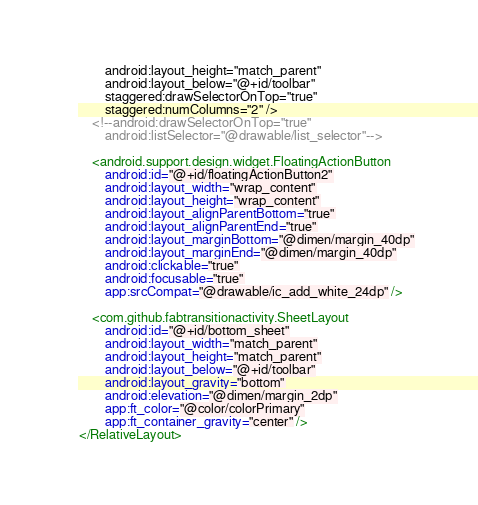Convert code to text. <code><loc_0><loc_0><loc_500><loc_500><_XML_>        android:layout_height="match_parent"
        android:layout_below="@+id/toolbar"
        staggered:drawSelectorOnTop="true"
        staggered:numColumns="2" />
    <!--android:drawSelectorOnTop="true"
        android:listSelector="@drawable/list_selector"-->

    <android.support.design.widget.FloatingActionButton
        android:id="@+id/floatingActionButton2"
        android:layout_width="wrap_content"
        android:layout_height="wrap_content"
        android:layout_alignParentBottom="true"
        android:layout_alignParentEnd="true"
        android:layout_marginBottom="@dimen/margin_40dp"
        android:layout_marginEnd="@dimen/margin_40dp"
        android:clickable="true"
        android:focusable="true"
        app:srcCompat="@drawable/ic_add_white_24dp" />

    <com.github.fabtransitionactivity.SheetLayout
        android:id="@+id/bottom_sheet"
        android:layout_width="match_parent"
        android:layout_height="match_parent"
        android:layout_below="@+id/toolbar"
        android:layout_gravity="bottom"
        android:elevation="@dimen/margin_2dp"
        app:ft_color="@color/colorPrimary"
        app:ft_container_gravity="center" />
</RelativeLayout></code> 